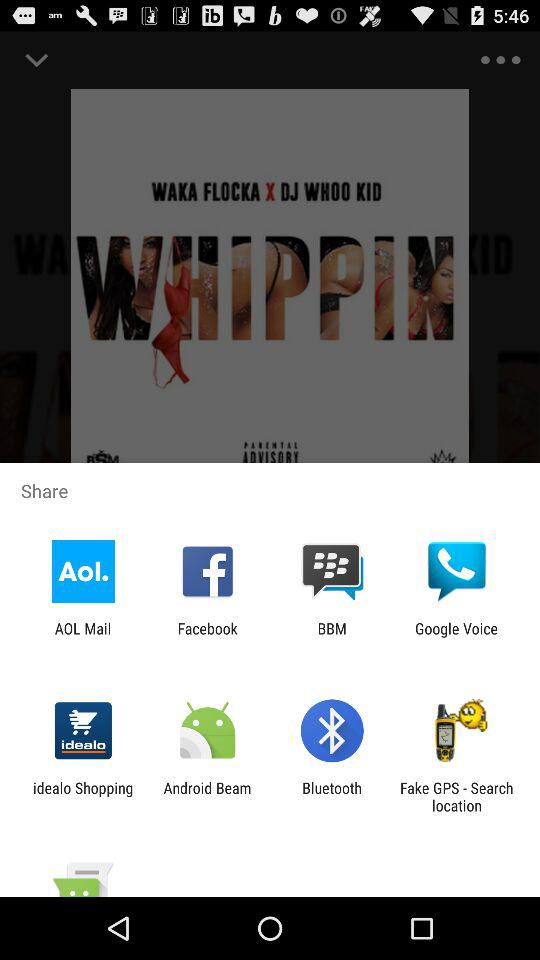Through what applications can content be shared? You can share it with "AOL Mail", "Facebook", "BBM", "Google Voice", "idealo Shopping", "Android Beam", "Bluetooth" and "Fake GPS - Search location". 